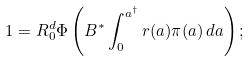Convert formula to latex. <formula><loc_0><loc_0><loc_500><loc_500>1 = R _ { 0 } ^ { d } \Phi \left ( B ^ { * } \int _ { 0 } ^ { a ^ { \dagger } } r ( a ) \pi ( a ) \, d a \right ) ;</formula> 